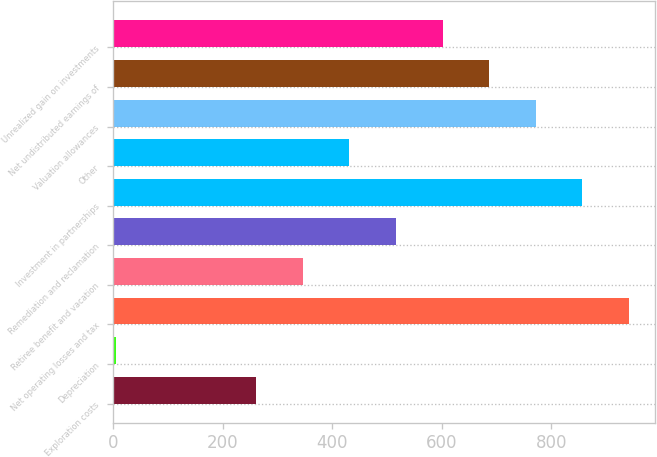Convert chart. <chart><loc_0><loc_0><loc_500><loc_500><bar_chart><fcel>Exploration costs<fcel>Depreciation<fcel>Net operating losses and tax<fcel>Retiree benefit and vacation<fcel>Remediation and reclamation<fcel>Investment in partnerships<fcel>Other<fcel>Valuation allowances<fcel>Net undistributed earnings of<fcel>Unrealized gain on investments<nl><fcel>261.3<fcel>6<fcel>942.1<fcel>346.4<fcel>516.6<fcel>857<fcel>431.5<fcel>771.9<fcel>686.8<fcel>601.7<nl></chart> 